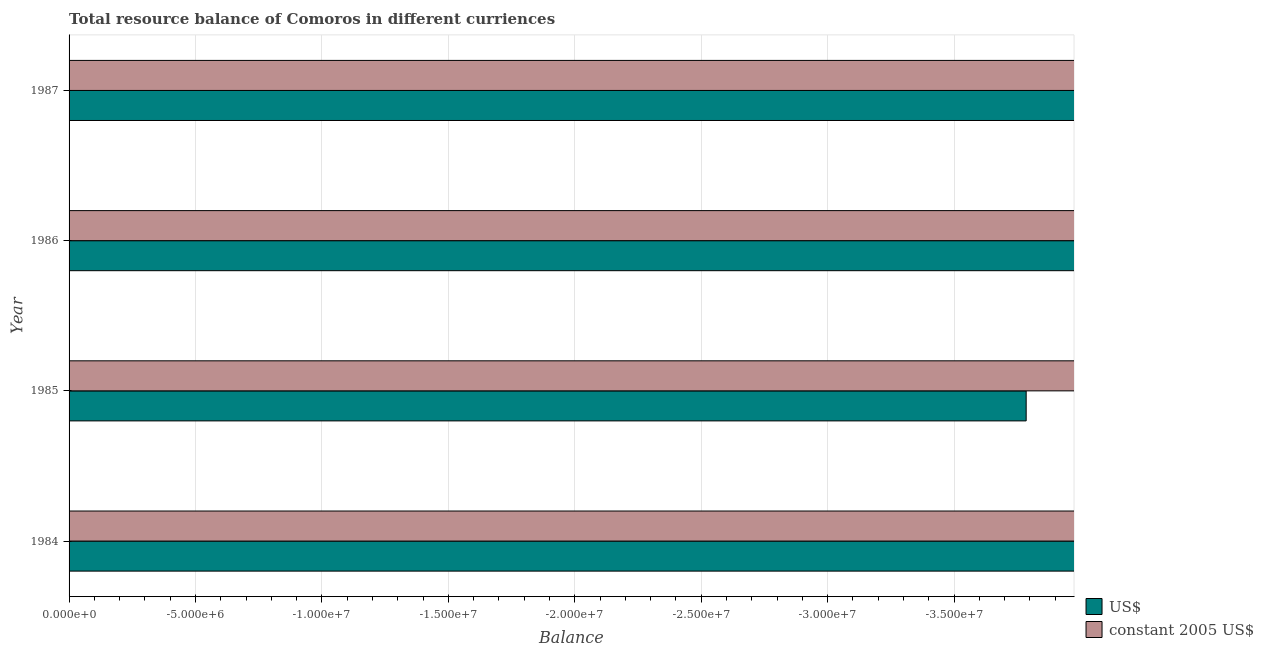How many different coloured bars are there?
Give a very brief answer. 0. In how many cases, is the number of bars for a given year not equal to the number of legend labels?
Give a very brief answer. 4. What is the resource balance in us$ in 1984?
Your answer should be compact. 0. What is the total resource balance in us$ in the graph?
Your response must be concise. 0. What is the average resource balance in constant us$ per year?
Keep it short and to the point. 0. In how many years, is the resource balance in us$ greater than -35000000 units?
Your answer should be very brief. 0. How many years are there in the graph?
Ensure brevity in your answer.  4. What is the difference between two consecutive major ticks on the X-axis?
Offer a very short reply. 5.00e+06. Does the graph contain any zero values?
Make the answer very short. Yes. Does the graph contain grids?
Ensure brevity in your answer.  Yes. Where does the legend appear in the graph?
Provide a succinct answer. Bottom right. What is the title of the graph?
Give a very brief answer. Total resource balance of Comoros in different curriences. What is the label or title of the X-axis?
Your response must be concise. Balance. What is the label or title of the Y-axis?
Provide a succinct answer. Year. What is the Balance in US$ in 1984?
Your answer should be very brief. 0. What is the Balance in constant 2005 US$ in 1984?
Your response must be concise. 0. What is the total Balance of US$ in the graph?
Ensure brevity in your answer.  0. What is the total Balance of constant 2005 US$ in the graph?
Offer a very short reply. 0. What is the average Balance in US$ per year?
Ensure brevity in your answer.  0. What is the average Balance in constant 2005 US$ per year?
Provide a short and direct response. 0. 